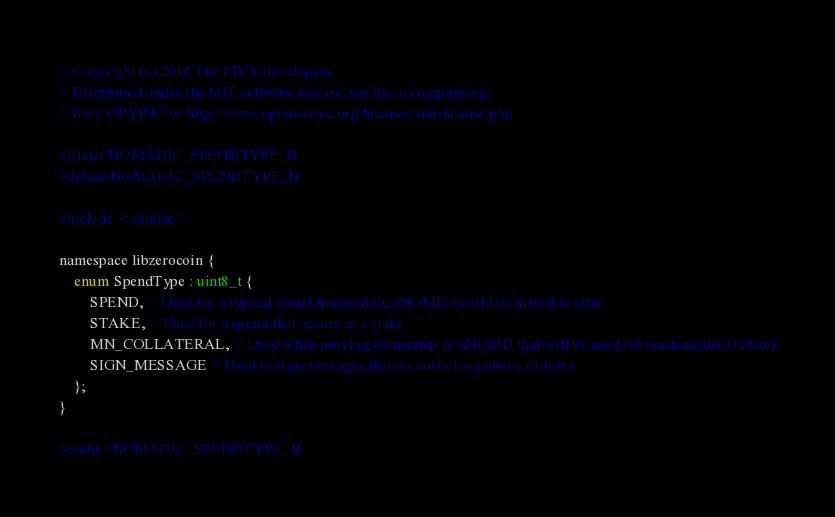Convert code to text. <code><loc_0><loc_0><loc_500><loc_500><_C_>// Copyright (c) 2018 The PIVX developers
// Distributed under the MIT software license, see the accompanying
// file COPYING or http://www.opensource.org/licenses/mit-license.php.

#ifndef NOMADIC_SPENDTYPE_H
#define NOMADIC_SPENDTYPE_H

#include <cstdint>

namespace libzerocoin {
    enum SpendType : uint8_t {
        SPEND, // Used for a typical spend transaction, zNOMD should be unusable after
        STAKE, // Used for a spend that occurs as a stake
        MN_COLLATERAL, // Used when proving ownership of zNOMD that will be used for masternodes (future)
        SIGN_MESSAGE // Used to sign messages that do not belong above (future)
    };
}

#endif //NOMADIC_SPENDTYPE_H
</code> 